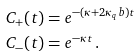<formula> <loc_0><loc_0><loc_500><loc_500>C _ { + } ( t ) & = e ^ { - ( \kappa + 2 \kappa _ { q } b ) t } \\ C _ { - } ( t ) & = e ^ { - \kappa t } \, .</formula> 